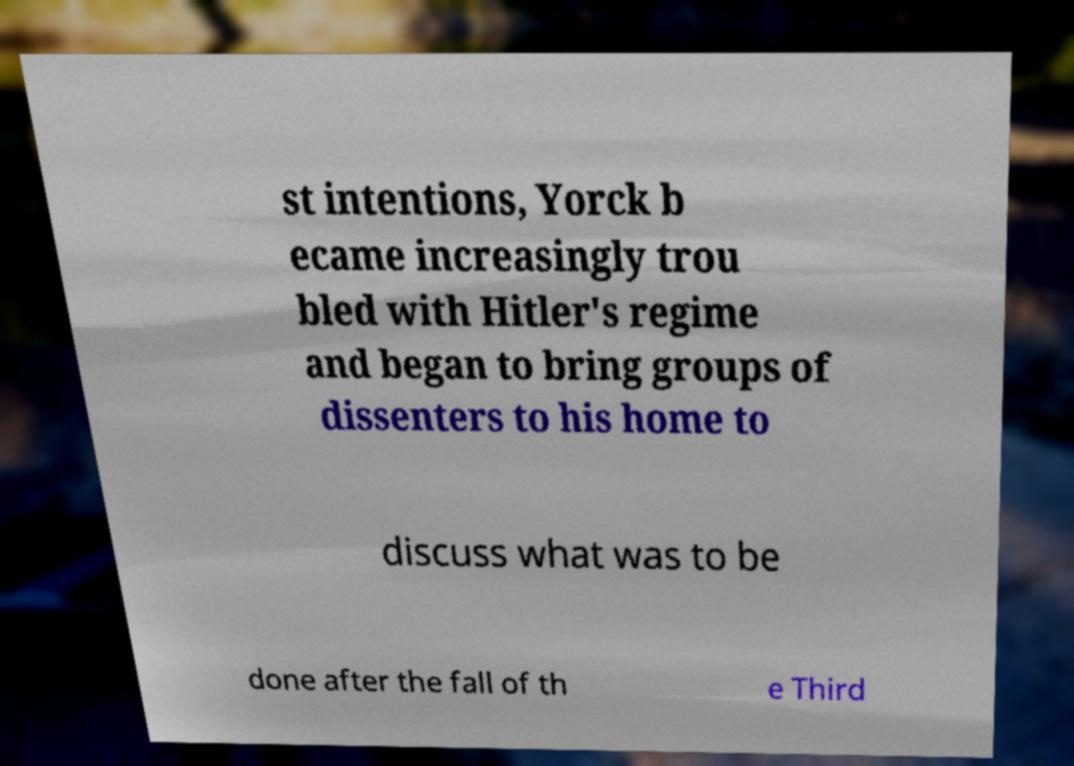Can you accurately transcribe the text from the provided image for me? st intentions, Yorck b ecame increasingly trou bled with Hitler's regime and began to bring groups of dissenters to his home to discuss what was to be done after the fall of th e Third 